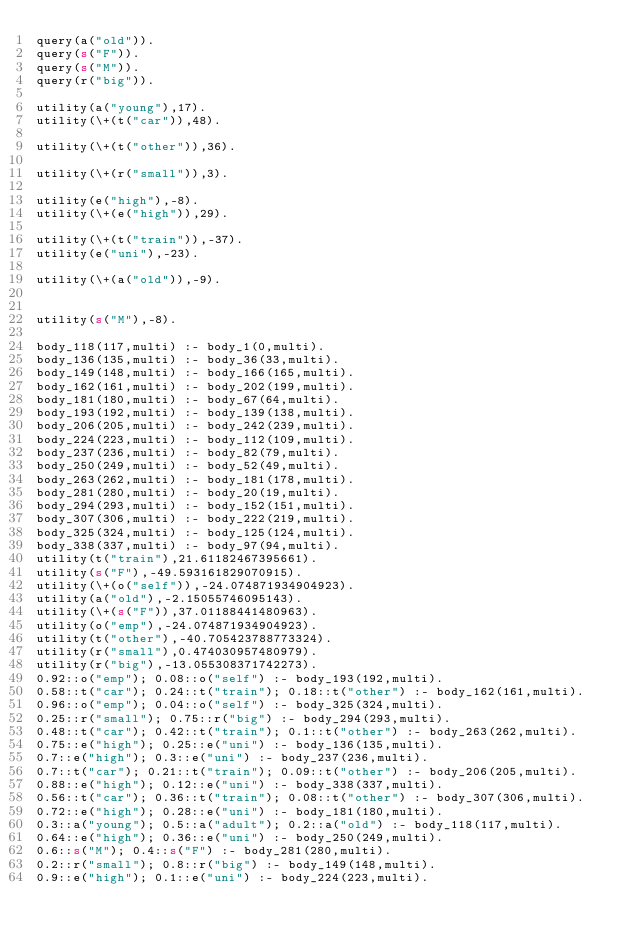Convert code to text. <code><loc_0><loc_0><loc_500><loc_500><_Perl_>query(a("old")).
query(s("F")).
query(s("M")).
query(r("big")).

utility(a("young"),17).
utility(\+(t("car")),48).

utility(\+(t("other")),36).

utility(\+(r("small")),3).

utility(e("high"),-8).
utility(\+(e("high")),29).

utility(\+(t("train")),-37).
utility(e("uni"),-23).

utility(\+(a("old")),-9).


utility(s("M"),-8).

body_118(117,multi) :- body_1(0,multi).
body_136(135,multi) :- body_36(33,multi).
body_149(148,multi) :- body_166(165,multi).
body_162(161,multi) :- body_202(199,multi).
body_181(180,multi) :- body_67(64,multi).
body_193(192,multi) :- body_139(138,multi).
body_206(205,multi) :- body_242(239,multi).
body_224(223,multi) :- body_112(109,multi).
body_237(236,multi) :- body_82(79,multi).
body_250(249,multi) :- body_52(49,multi).
body_263(262,multi) :- body_181(178,multi).
body_281(280,multi) :- body_20(19,multi).
body_294(293,multi) :- body_152(151,multi).
body_307(306,multi) :- body_222(219,multi).
body_325(324,multi) :- body_125(124,multi).
body_338(337,multi) :- body_97(94,multi).
utility(t("train"),21.61182467395661).
utility(s("F"),-49.593161829070915).
utility(\+(o("self")),-24.074871934904923).
utility(a("old"),-2.15055746095143).
utility(\+(s("F")),37.01188441480963).
utility(o("emp"),-24.074871934904923).
utility(t("other"),-40.705423788773324).
utility(r("small"),0.474030957480979).
utility(r("big"),-13.055308371742273).
0.92::o("emp"); 0.08::o("self") :- body_193(192,multi).
0.58::t("car"); 0.24::t("train"); 0.18::t("other") :- body_162(161,multi).
0.96::o("emp"); 0.04::o("self") :- body_325(324,multi).
0.25::r("small"); 0.75::r("big") :- body_294(293,multi).
0.48::t("car"); 0.42::t("train"); 0.1::t("other") :- body_263(262,multi).
0.75::e("high"); 0.25::e("uni") :- body_136(135,multi).
0.7::e("high"); 0.3::e("uni") :- body_237(236,multi).
0.7::t("car"); 0.21::t("train"); 0.09::t("other") :- body_206(205,multi).
0.88::e("high"); 0.12::e("uni") :- body_338(337,multi).
0.56::t("car"); 0.36::t("train"); 0.08::t("other") :- body_307(306,multi).
0.72::e("high"); 0.28::e("uni") :- body_181(180,multi).
0.3::a("young"); 0.5::a("adult"); 0.2::a("old") :- body_118(117,multi).
0.64::e("high"); 0.36::e("uni") :- body_250(249,multi).
0.6::s("M"); 0.4::s("F") :- body_281(280,multi).
0.2::r("small"); 0.8::r("big") :- body_149(148,multi).
0.9::e("high"); 0.1::e("uni") :- body_224(223,multi).
</code> 